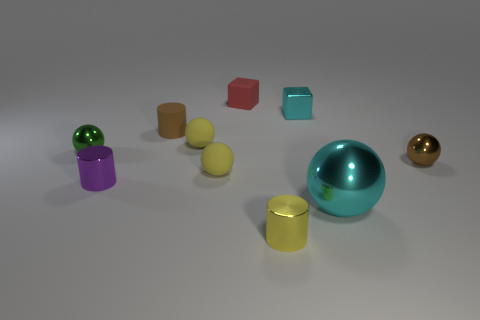What material is the tiny yellow sphere behind the tiny metallic sphere that is left of the purple shiny thing made of?
Your answer should be compact. Rubber. There is a green thing that is the same shape as the big cyan shiny thing; what material is it?
Ensure brevity in your answer.  Metal. Does the cyan object that is in front of the purple metallic object have the same size as the yellow cylinder?
Provide a short and direct response. No. How many matte objects are either things or purple cylinders?
Provide a succinct answer. 4. What is the yellow object that is in front of the tiny green metal thing and behind the big cyan thing made of?
Offer a terse response. Rubber. Does the small purple object have the same material as the large cyan sphere?
Ensure brevity in your answer.  Yes. There is a metal object that is both on the left side of the small shiny block and on the right side of the small brown rubber thing; what is its size?
Ensure brevity in your answer.  Small. There is a tiny cyan object; what shape is it?
Give a very brief answer. Cube. What number of things are cyan spheres or large cyan things in front of the small cyan metal block?
Ensure brevity in your answer.  1. Does the metal sphere that is left of the tiny yellow cylinder have the same color as the small matte cube?
Your answer should be very brief. No. 